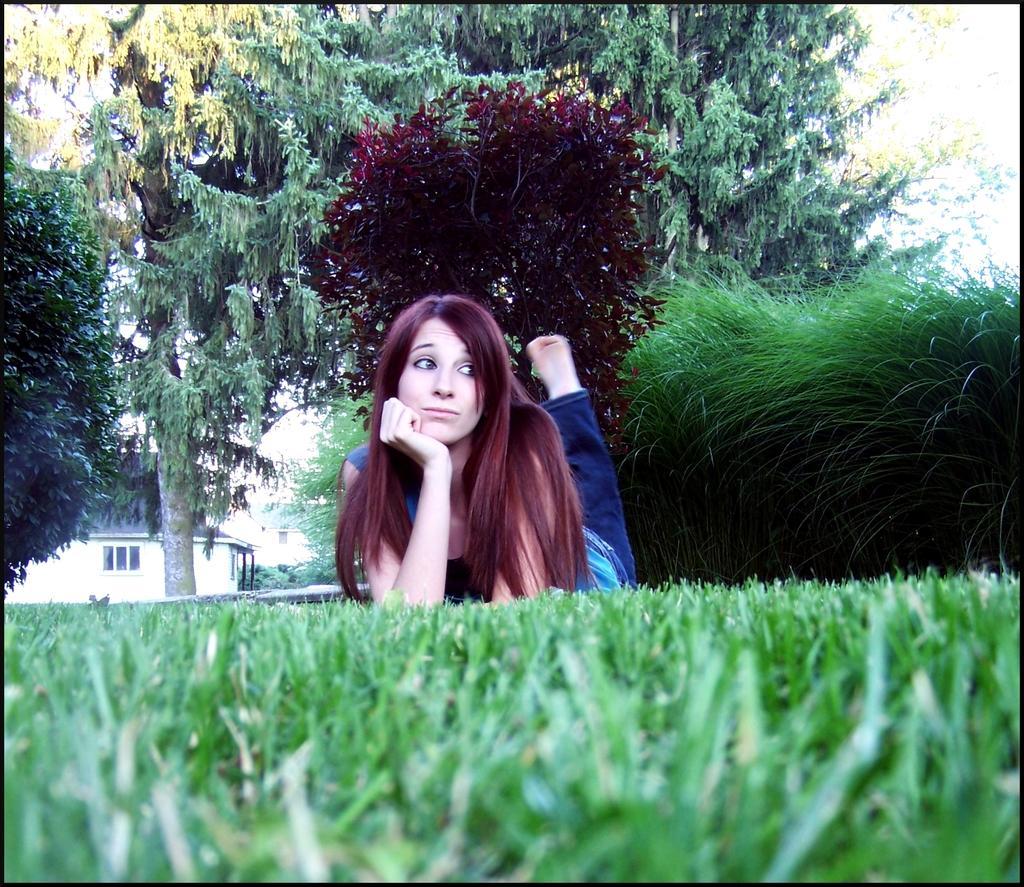In one or two sentences, can you explain what this image depicts? In the image in the center we can see one woman lying on the grass. In the background we can see sky,trees,building,wall,roof,window,plants and grass. 